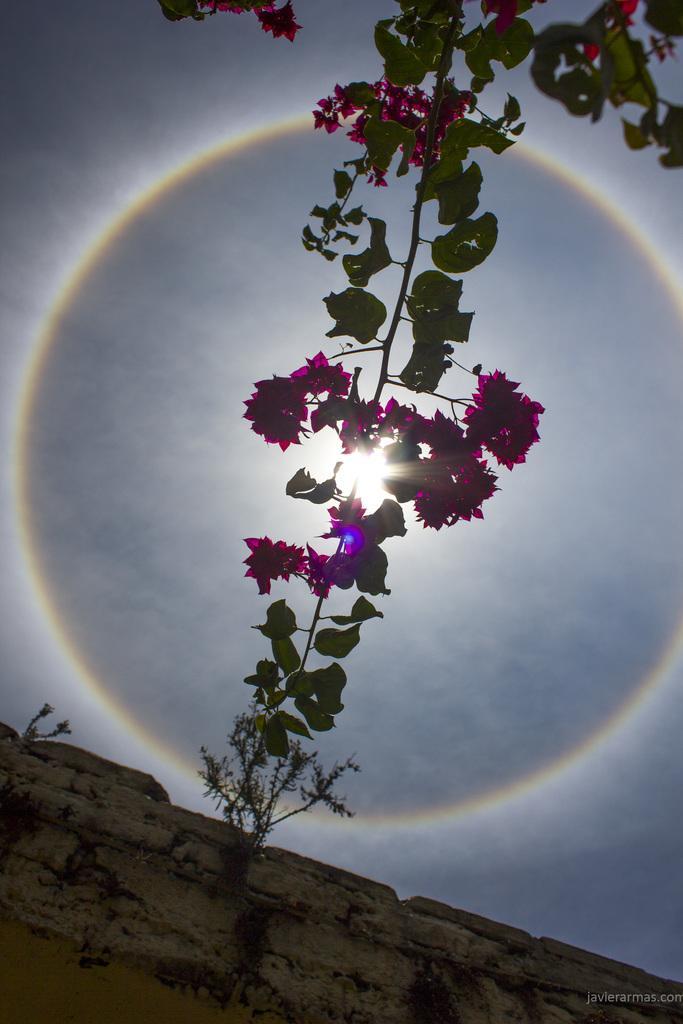Please provide a concise description of this image. In this image there is a stem having flowers and leaves. There are plants on the wall. Background there is sky having a son. 